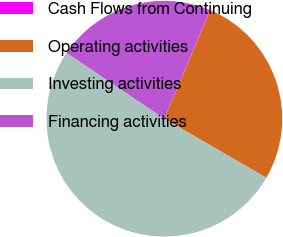Convert chart to OTSL. <chart><loc_0><loc_0><loc_500><loc_500><pie_chart><fcel>Cash Flows from Continuing<fcel>Operating activities<fcel>Investing activities<fcel>Financing activities<nl><fcel>0.07%<fcel>26.98%<fcel>51.07%<fcel>21.88%<nl></chart> 